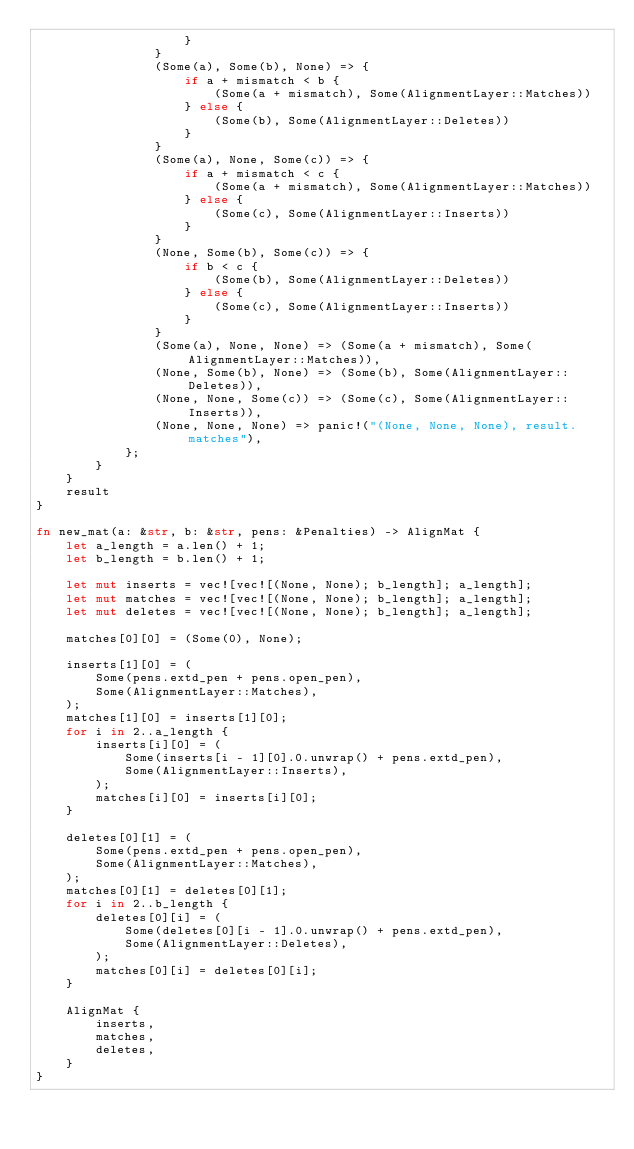Convert code to text. <code><loc_0><loc_0><loc_500><loc_500><_Rust_>                    }
                }
                (Some(a), Some(b), None) => {
                    if a + mismatch < b {
                        (Some(a + mismatch), Some(AlignmentLayer::Matches))
                    } else {
                        (Some(b), Some(AlignmentLayer::Deletes))
                    }
                }
                (Some(a), None, Some(c)) => {
                    if a + mismatch < c {
                        (Some(a + mismatch), Some(AlignmentLayer::Matches))
                    } else {
                        (Some(c), Some(AlignmentLayer::Inserts))
                    }
                }
                (None, Some(b), Some(c)) => {
                    if b < c {
                        (Some(b), Some(AlignmentLayer::Deletes))
                    } else {
                        (Some(c), Some(AlignmentLayer::Inserts))
                    }
                }
                (Some(a), None, None) => (Some(a + mismatch), Some(AlignmentLayer::Matches)),
                (None, Some(b), None) => (Some(b), Some(AlignmentLayer::Deletes)),
                (None, None, Some(c)) => (Some(c), Some(AlignmentLayer::Inserts)),
                (None, None, None) => panic!("(None, None, None), result.matches"),
            };
        }
    }
    result
}

fn new_mat(a: &str, b: &str, pens: &Penalties) -> AlignMat {
    let a_length = a.len() + 1;
    let b_length = b.len() + 1;

    let mut inserts = vec![vec![(None, None); b_length]; a_length];
    let mut matches = vec![vec![(None, None); b_length]; a_length];
    let mut deletes = vec![vec![(None, None); b_length]; a_length];

    matches[0][0] = (Some(0), None);

    inserts[1][0] = (
        Some(pens.extd_pen + pens.open_pen),
        Some(AlignmentLayer::Matches),
    );
    matches[1][0] = inserts[1][0];
    for i in 2..a_length {
        inserts[i][0] = (
            Some(inserts[i - 1][0].0.unwrap() + pens.extd_pen),
            Some(AlignmentLayer::Inserts),
        );
        matches[i][0] = inserts[i][0];
    }

    deletes[0][1] = (
        Some(pens.extd_pen + pens.open_pen),
        Some(AlignmentLayer::Matches),
    );
    matches[0][1] = deletes[0][1];
    for i in 2..b_length {
        deletes[0][i] = (
            Some(deletes[0][i - 1].0.unwrap() + pens.extd_pen),
            Some(AlignmentLayer::Deletes),
        );
        matches[0][i] = deletes[0][i];
    }

    AlignMat {
        inserts,
        matches,
        deletes,
    }
}
</code> 